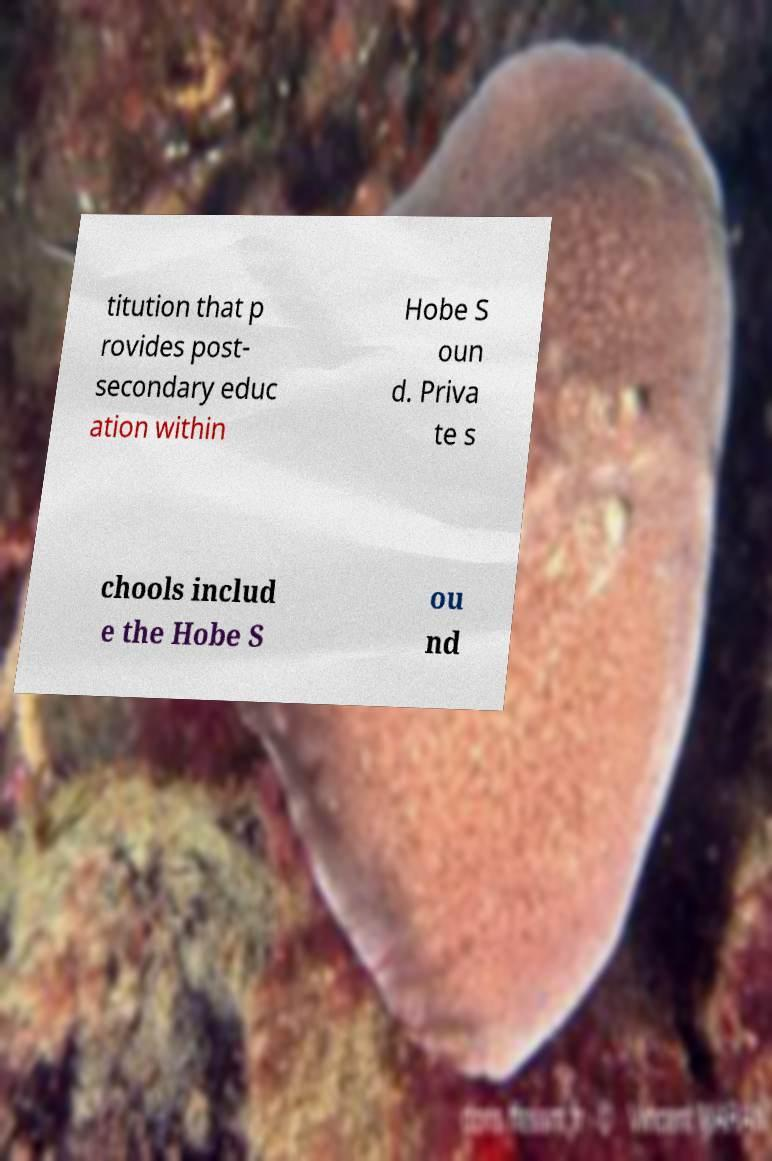There's text embedded in this image that I need extracted. Can you transcribe it verbatim? titution that p rovides post- secondary educ ation within Hobe S oun d. Priva te s chools includ e the Hobe S ou nd 